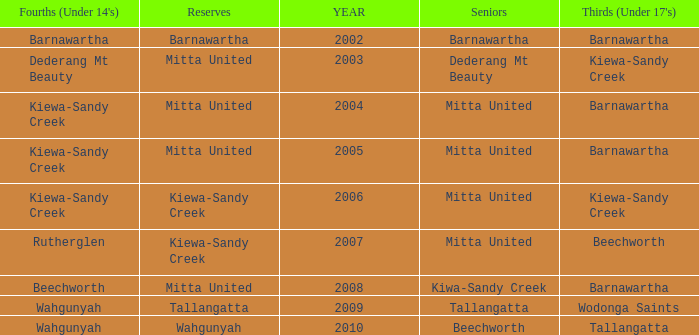Which Seniors have YEAR before 2006, and Fourths (Under 14's) of kiewa-sandy creek? Mitta United, Mitta United. 